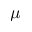Convert formula to latex. <formula><loc_0><loc_0><loc_500><loc_500>\mu</formula> 